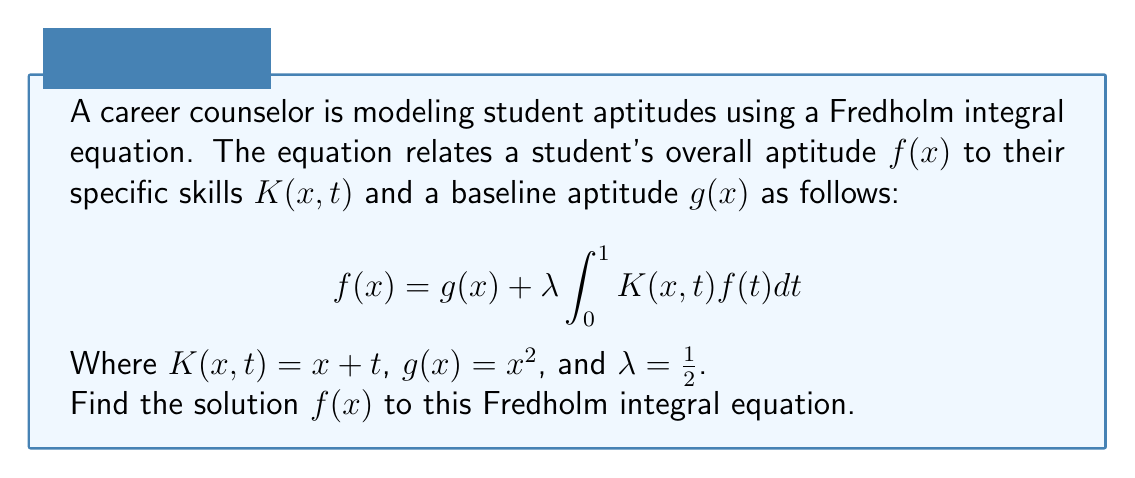Show me your answer to this math problem. Let's solve this step-by-step:

1) We start with the given Fredholm integral equation:
   $$f(x) = x^2 + \frac{1}{2} \int_0^1 (x+t)f(t)dt$$

2) Let's assume that the solution is of the form:
   $$f(x) = ax^2 + bx + c$$

3) Substituting this into the right-hand side of the equation:
   $$x^2 + \frac{1}{2} \int_0^1 (x+t)(at^2 + bt + c)dt$$

4) Expanding the integral:
   $$x^2 + \frac{1}{2} \left(x\int_0^1 (at^2 + bt + c)dt + \int_0^1 (at^3 + bt^2 + ct)dt\right)$$

5) Evaluating the integrals:
   $$x^2 + \frac{1}{2} \left(x\left(\frac{a}{3} + \frac{b}{2} + c\right) + \left(\frac{a}{4} + \frac{b}{3} + \frac{c}{2}\right)\right)$$

6) Simplifying:
   $$x^2 + \frac{1}{2}\left(\frac{a}{3} + \frac{b}{2} + c\right)x + \frac{1}{2}\left(\frac{a}{4} + \frac{b}{3} + \frac{c}{2}\right)$$

7) Equating coefficients with $ax^2 + bx + c$:
   $$a = 1$$
   $$b = \frac{1}{2}\left(\frac{a}{3} + \frac{b}{2} + c\right)$$
   $$c = \frac{1}{2}\left(\frac{a}{4} + \frac{b}{3} + \frac{c}{2}\right)$$

8) From the first equation, $a = 1$. Substituting this into the other equations:
   $$b = \frac{1}{6} + \frac{b}{4} + \frac{c}{2}$$
   $$c = \frac{1}{8} + \frac{b}{6} + \frac{c}{4}$$

9) Solving these equations:
   $$b = \frac{2}{9}, c = \frac{2}{27}$$

Therefore, the solution is:
$$f(x) = x^2 + \frac{2}{9}x + \frac{2}{27}$$
Answer: $f(x) = x^2 + \frac{2}{9}x + \frac{2}{27}$ 